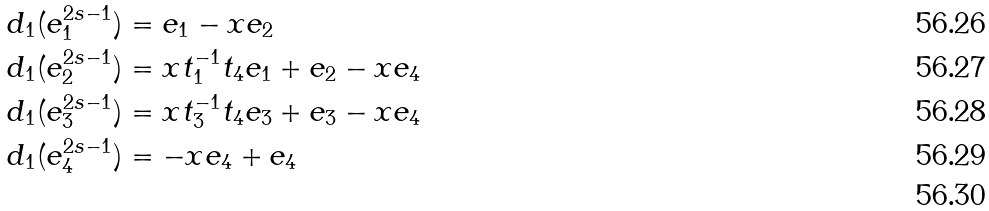Convert formula to latex. <formula><loc_0><loc_0><loc_500><loc_500>d _ { 1 } ( e _ { 1 } ^ { 2 s - 1 } ) & = e _ { 1 } - x e _ { 2 } \\ d _ { 1 } ( e _ { 2 } ^ { 2 s - 1 } ) & = x t _ { 1 } ^ { - 1 } t _ { 4 } e _ { 1 } + e _ { 2 } - x e _ { 4 } \\ d _ { 1 } ( e _ { 3 } ^ { 2 s - 1 } ) & = x t _ { 3 } ^ { - 1 } t _ { 4 } e _ { 3 } + e _ { 3 } - x e _ { 4 } \\ d _ { 1 } ( e _ { 4 } ^ { 2 s - 1 } ) & = - x e _ { 4 } + e _ { 4 } \\</formula> 